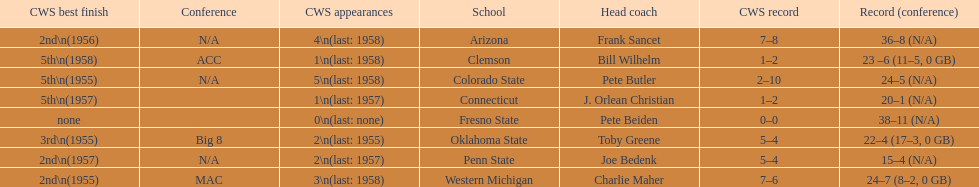What are the listed schools? Arizona, Clemson, Colorado State, Connecticut, Fresno State, Oklahoma State, Penn State, Western Michigan. Which are clemson and western michigan? Clemson, Western Michigan. What are their corresponding numbers of cws appearances? 1\n(last: 1958), 3\n(last: 1958). Which value is larger? 3\n(last: 1958). To which school does that value belong to? Western Michigan. 